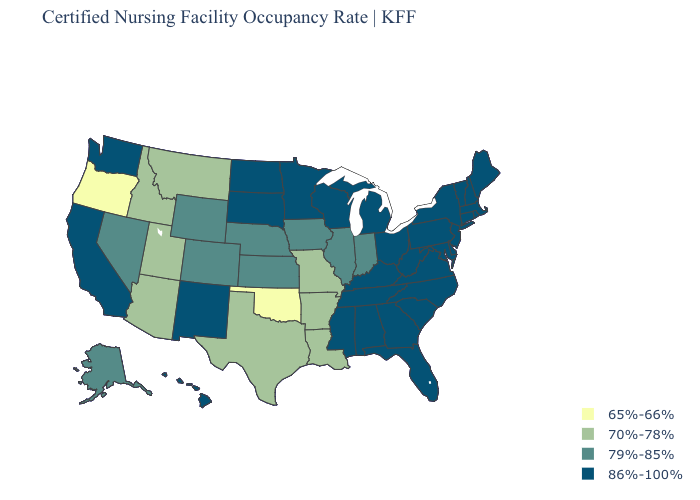What is the value of Kentucky?
Concise answer only. 86%-100%. Name the states that have a value in the range 79%-85%?
Answer briefly. Alaska, Colorado, Illinois, Indiana, Iowa, Kansas, Nebraska, Nevada, Wyoming. Name the states that have a value in the range 79%-85%?
Keep it brief. Alaska, Colorado, Illinois, Indiana, Iowa, Kansas, Nebraska, Nevada, Wyoming. Name the states that have a value in the range 79%-85%?
Short answer required. Alaska, Colorado, Illinois, Indiana, Iowa, Kansas, Nebraska, Nevada, Wyoming. Name the states that have a value in the range 65%-66%?
Answer briefly. Oklahoma, Oregon. Does Oregon have the lowest value in the West?
Quick response, please. Yes. Which states have the highest value in the USA?
Keep it brief. Alabama, California, Connecticut, Delaware, Florida, Georgia, Hawaii, Kentucky, Maine, Maryland, Massachusetts, Michigan, Minnesota, Mississippi, New Hampshire, New Jersey, New Mexico, New York, North Carolina, North Dakota, Ohio, Pennsylvania, Rhode Island, South Carolina, South Dakota, Tennessee, Vermont, Virginia, Washington, West Virginia, Wisconsin. What is the highest value in states that border Tennessee?
Write a very short answer. 86%-100%. Among the states that border New Jersey , which have the highest value?
Short answer required. Delaware, New York, Pennsylvania. What is the lowest value in the West?
Quick response, please. 65%-66%. What is the value of Delaware?
Keep it brief. 86%-100%. What is the highest value in states that border Illinois?
Write a very short answer. 86%-100%. Name the states that have a value in the range 86%-100%?
Answer briefly. Alabama, California, Connecticut, Delaware, Florida, Georgia, Hawaii, Kentucky, Maine, Maryland, Massachusetts, Michigan, Minnesota, Mississippi, New Hampshire, New Jersey, New Mexico, New York, North Carolina, North Dakota, Ohio, Pennsylvania, Rhode Island, South Carolina, South Dakota, Tennessee, Vermont, Virginia, Washington, West Virginia, Wisconsin. What is the value of Utah?
Concise answer only. 70%-78%. 